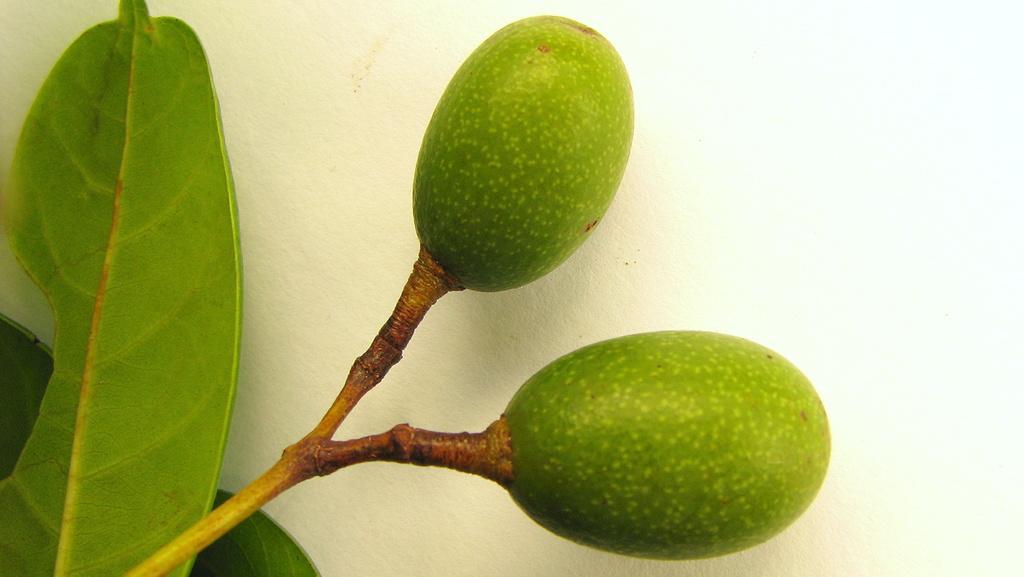Could you give a brief overview of what you see in this image? In the picture we can see a plant stem and leaves and two fruits to it which are green in color and behind it we can see a wall. 